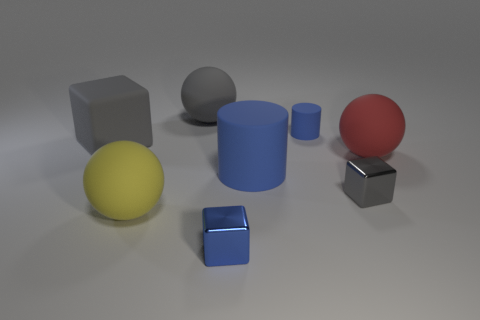What shape is the small metallic object that is the same color as the large rubber cylinder?
Your response must be concise. Cube. How big is the gray thing that is in front of the blue cylinder left of the blue cylinder behind the large rubber cylinder?
Your answer should be compact. Small. There is a blue metal object; does it have the same shape as the gray object in front of the red thing?
Your answer should be compact. Yes. The cube that is made of the same material as the large red object is what size?
Provide a succinct answer. Large. Is there anything else that has the same color as the large block?
Make the answer very short. Yes. The gray object in front of the gray matte thing in front of the big gray matte object that is right of the big gray rubber cube is made of what material?
Offer a very short reply. Metal. What number of metal things are either large gray blocks or red things?
Give a very brief answer. 0. Is the color of the small rubber thing the same as the big cylinder?
Keep it short and to the point. Yes. What number of objects are small red rubber things or big objects that are left of the large gray matte sphere?
Give a very brief answer. 2. Does the gray rubber thing on the right side of the yellow rubber object have the same size as the big blue matte thing?
Your answer should be compact. Yes. 